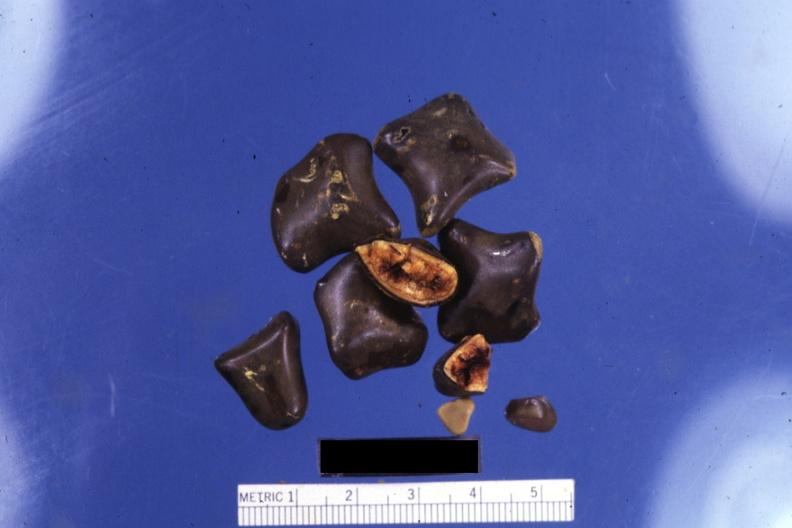what does this image show?
Answer the question using a single word or phrase. Close-up of faceted mixed stones with two showing cut surfaces 